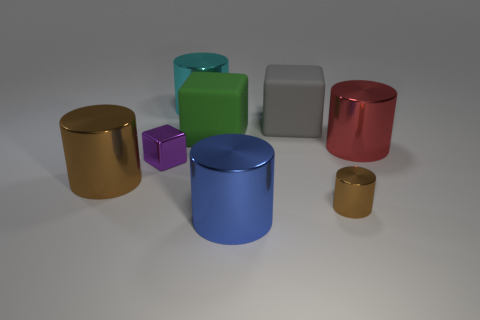What number of other objects are the same material as the big cyan cylinder?
Your answer should be compact. 5. Does the big gray cube have the same material as the small thing on the right side of the cyan object?
Give a very brief answer. No. Is the number of large rubber things that are behind the cyan cylinder less than the number of metal cylinders left of the blue shiny cylinder?
Give a very brief answer. Yes. The tiny cylinder in front of the big cyan cylinder is what color?
Keep it short and to the point. Brown. What number of other things are there of the same color as the shiny block?
Provide a succinct answer. 0. There is a object that is behind the gray matte block; is its size the same as the small shiny cylinder?
Offer a very short reply. No. How many gray blocks are left of the large blue metallic object?
Offer a very short reply. 0. Is there a brown thing that has the same size as the purple shiny cube?
Give a very brief answer. Yes. The matte cube that is on the left side of the blue object in front of the small block is what color?
Offer a very short reply. Green. What number of big metal objects are both on the left side of the metallic block and to the right of the small shiny cylinder?
Give a very brief answer. 0. 